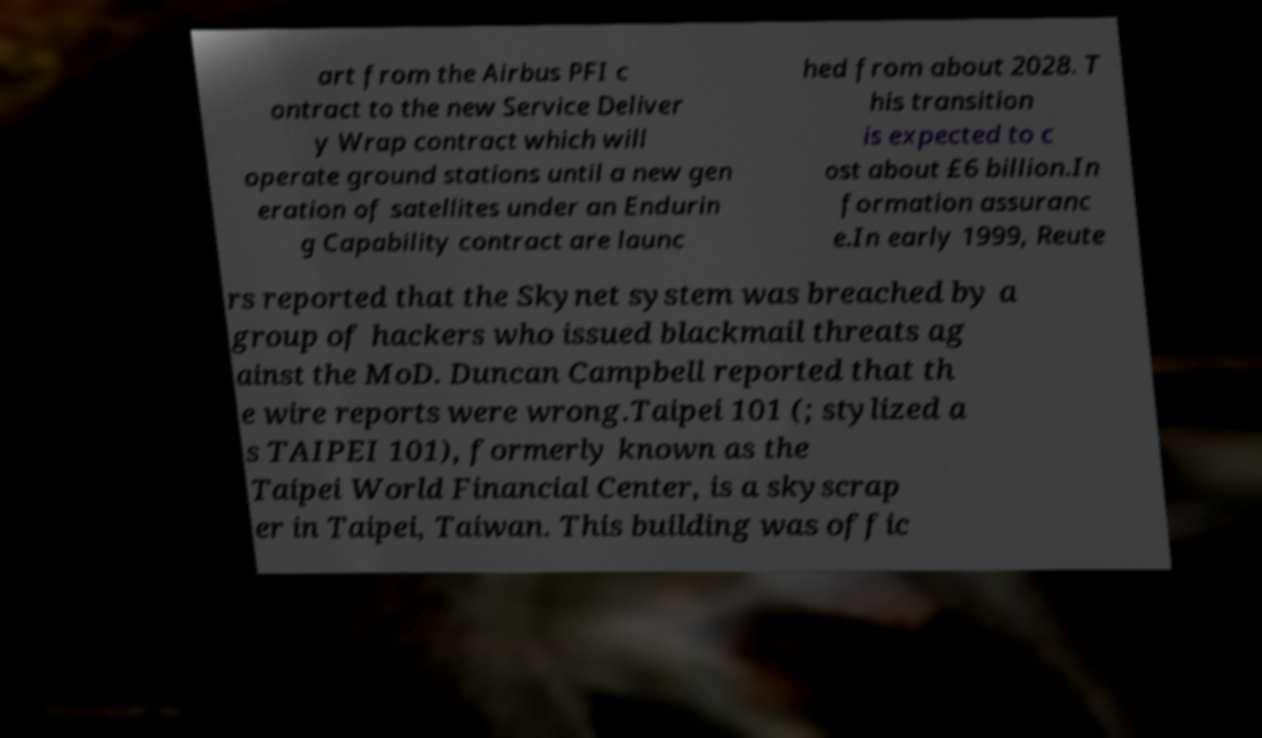Could you extract and type out the text from this image? art from the Airbus PFI c ontract to the new Service Deliver y Wrap contract which will operate ground stations until a new gen eration of satellites under an Endurin g Capability contract are launc hed from about 2028. T his transition is expected to c ost about £6 billion.In formation assuranc e.In early 1999, Reute rs reported that the Skynet system was breached by a group of hackers who issued blackmail threats ag ainst the MoD. Duncan Campbell reported that th e wire reports were wrong.Taipei 101 (; stylized a s TAIPEI 101), formerly known as the Taipei World Financial Center, is a skyscrap er in Taipei, Taiwan. This building was offic 